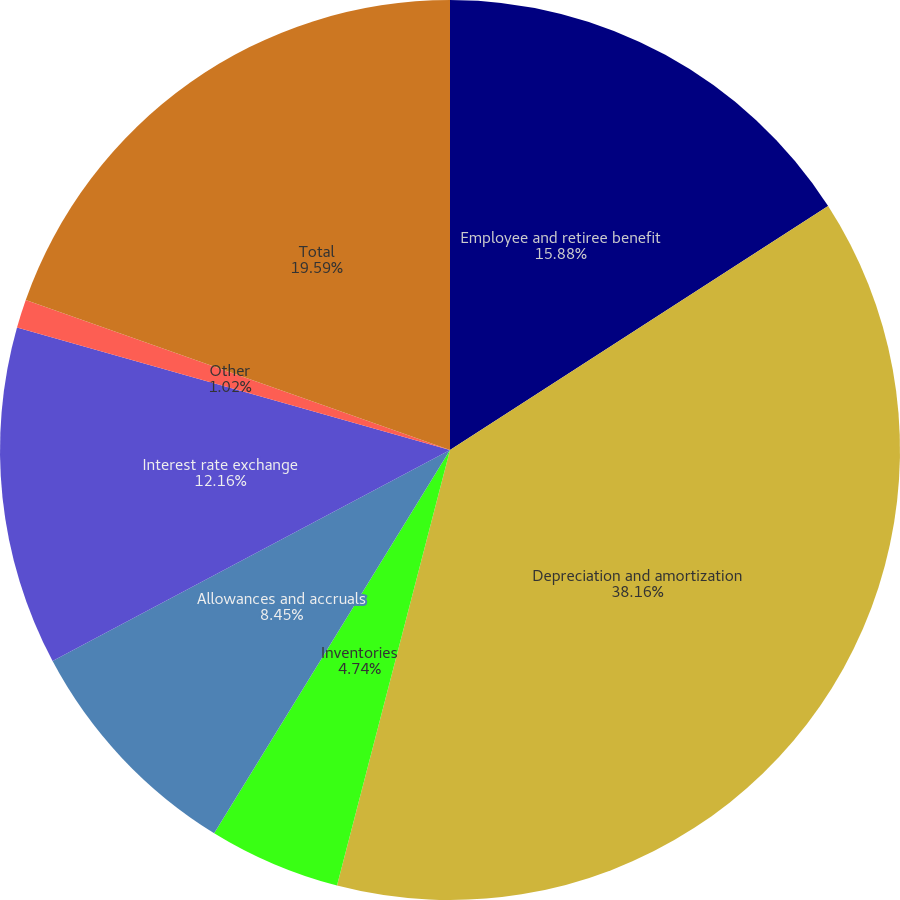Convert chart to OTSL. <chart><loc_0><loc_0><loc_500><loc_500><pie_chart><fcel>Employee and retiree benefit<fcel>Depreciation and amortization<fcel>Inventories<fcel>Allowances and accruals<fcel>Interest rate exchange<fcel>Other<fcel>Total<nl><fcel>15.88%<fcel>38.16%<fcel>4.74%<fcel>8.45%<fcel>12.16%<fcel>1.02%<fcel>19.59%<nl></chart> 